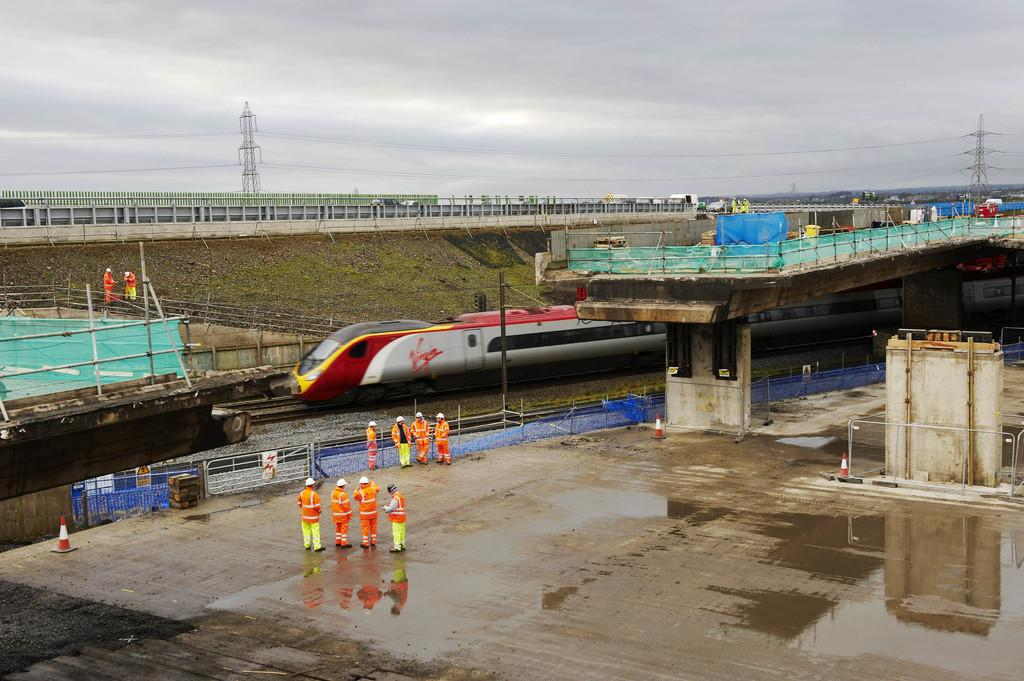Provide a one-sentence caption for the provided image. A Virgin brand train is outside on the track. 